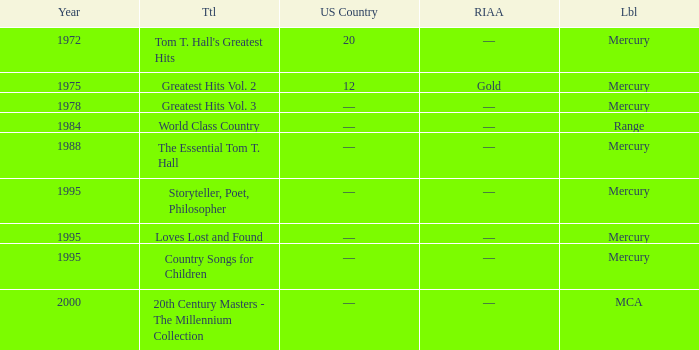What is the title of the album that had a RIAA of gold? Greatest Hits Vol. 2. 